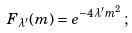Convert formula to latex. <formula><loc_0><loc_0><loc_500><loc_500>F _ { \lambda ^ { \prime } } ( m ) = e ^ { - 4 \lambda ^ { \prime } m ^ { 2 } } \, ;</formula> 